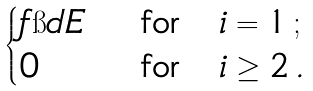<formula> <loc_0><loc_0><loc_500><loc_500>\begin{cases} f \i d E & \text { for} \quad i = 1 \, ; \\ 0 & \text { for} \quad i \geq 2 \, . \end{cases}</formula> 